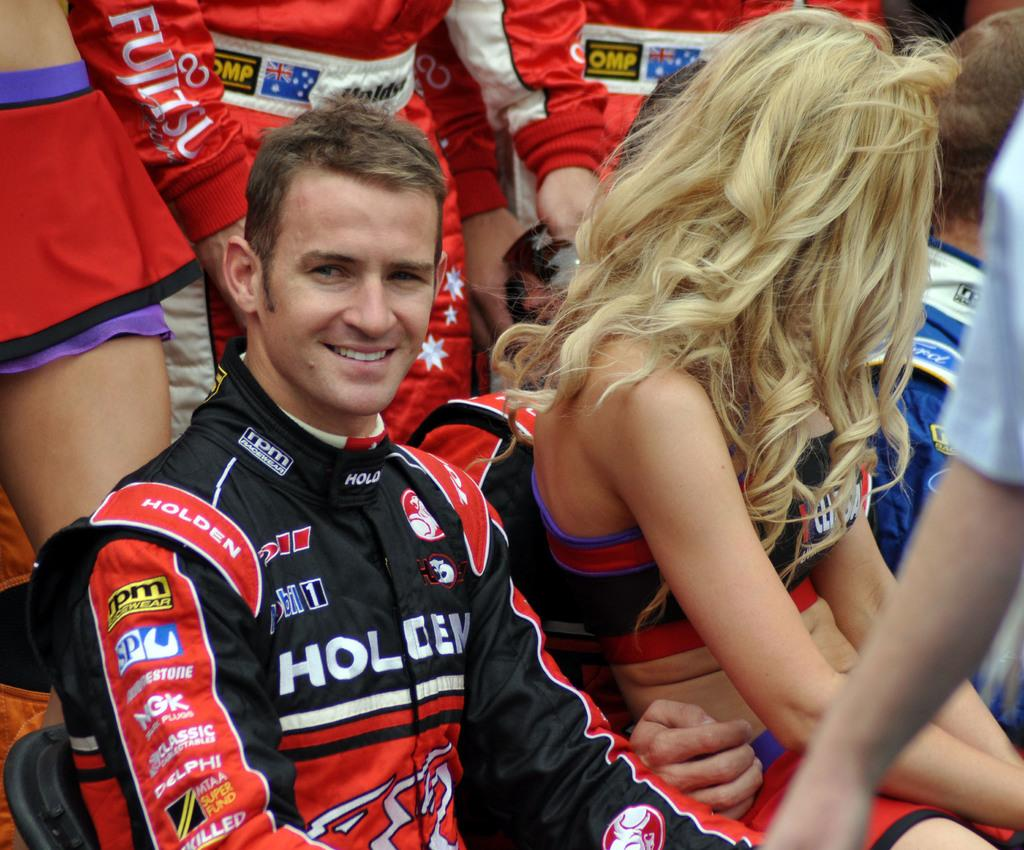<image>
Present a compact description of the photo's key features. A man wearing a Holoen race shirt next to some women. 